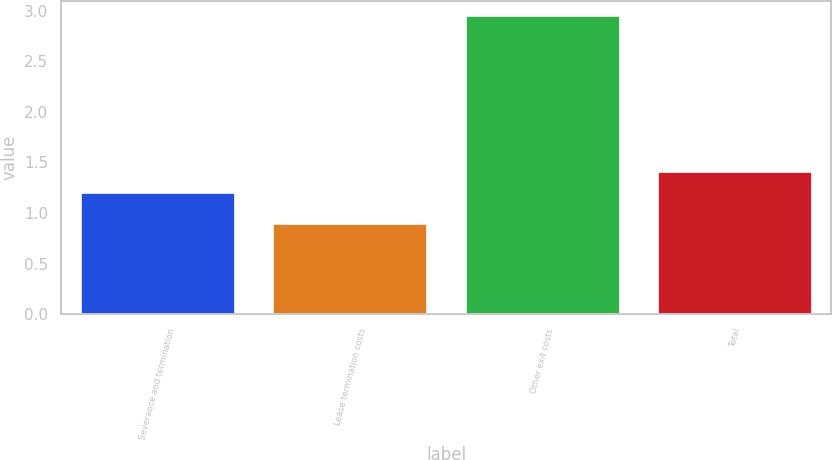Convert chart. <chart><loc_0><loc_0><loc_500><loc_500><bar_chart><fcel>Severance and termination<fcel>Lease termination costs<fcel>Other exit costs<fcel>Total<nl><fcel>1.2<fcel>0.89<fcel>2.95<fcel>1.41<nl></chart> 